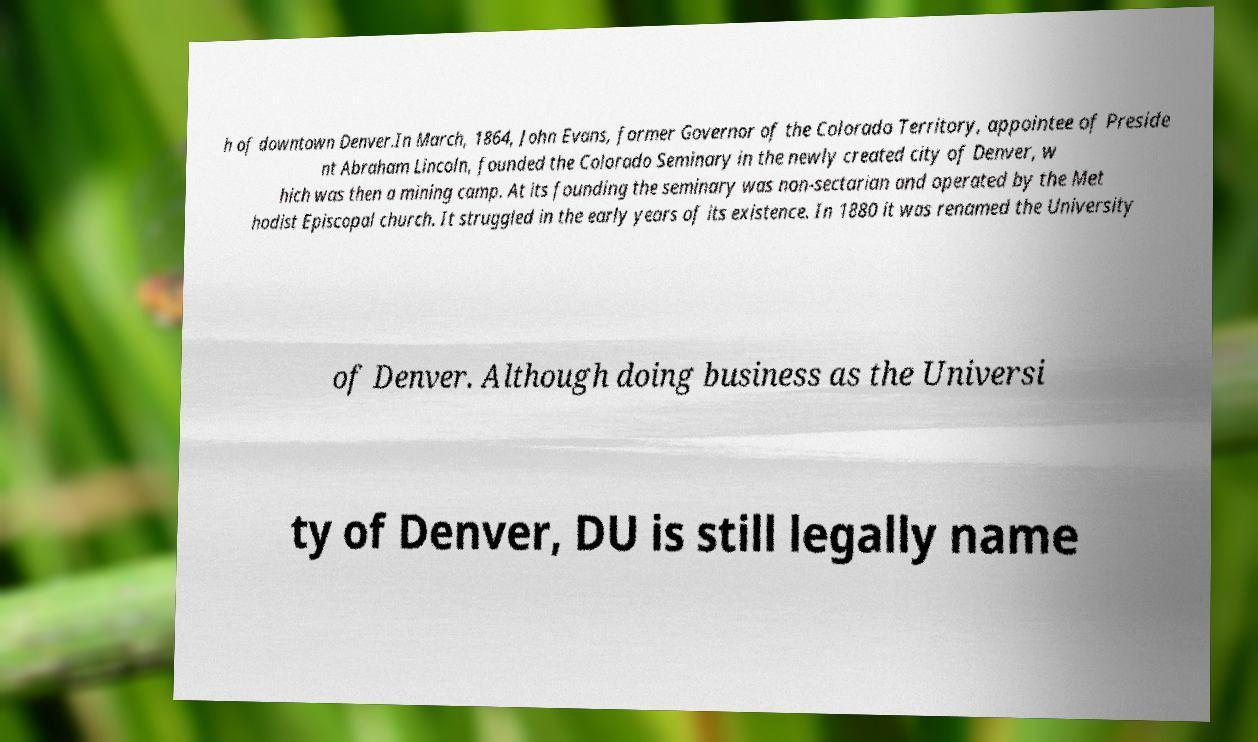Can you read and provide the text displayed in the image?This photo seems to have some interesting text. Can you extract and type it out for me? h of downtown Denver.In March, 1864, John Evans, former Governor of the Colorado Territory, appointee of Preside nt Abraham Lincoln, founded the Colorado Seminary in the newly created city of Denver, w hich was then a mining camp. At its founding the seminary was non-sectarian and operated by the Met hodist Episcopal church. It struggled in the early years of its existence. In 1880 it was renamed the University of Denver. Although doing business as the Universi ty of Denver, DU is still legally name 